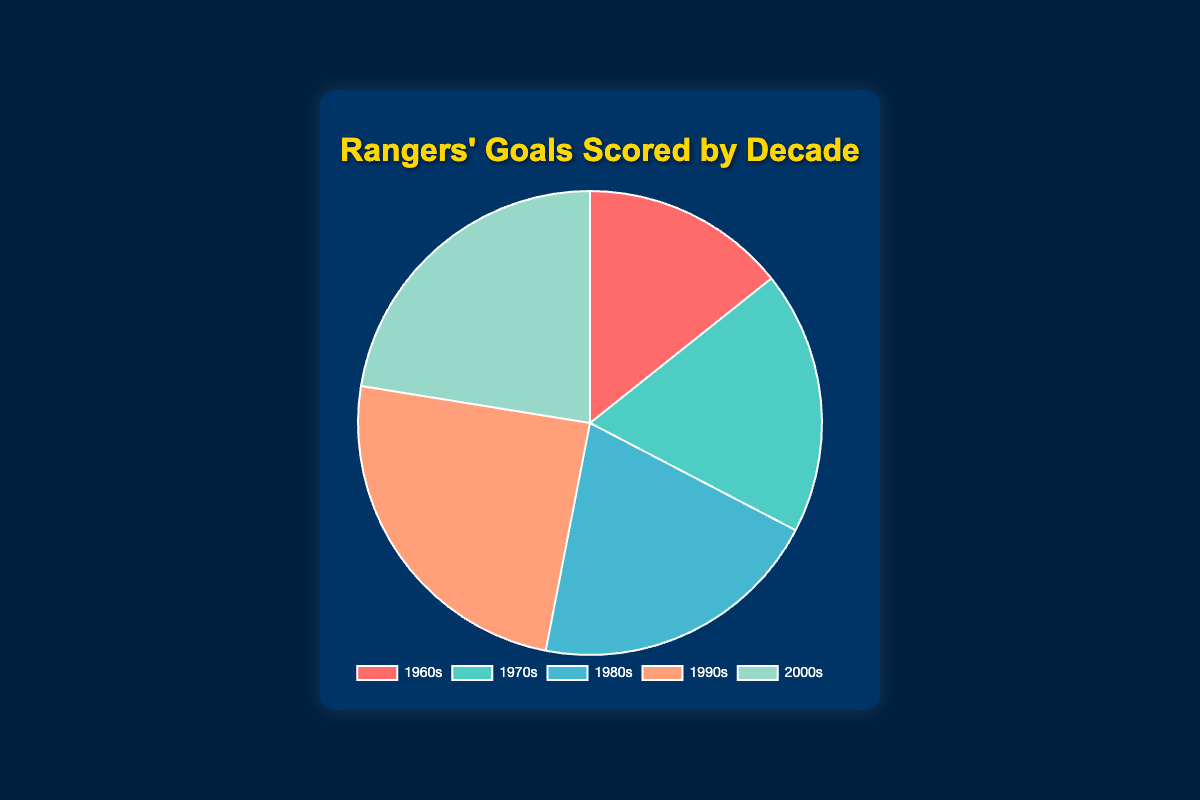What's the total number of goals scored across all decades? Add the goals scored in each decade: 350 (1960s) + 450 (1970s) + 500 (1980s) + 600 (1990s) + 550 (2000s) = 2450
Answer: 2450 Which decade has the highest number of goals scored? Look at the chart to identify the decade with the largest slice. The 1990s have the largest slice, representing 600 goals.
Answer: 1990s How many more goals were scored in the 1990s compared to the 1960s? Subtract the number of goals scored in the 1960s from the goals scored in the 1990s: 600 (1990s) - 350 (1960s) = 250
Answer: 250 What's the average number of goals scored per decade? Sum all the goals and divide by the number of decades: (350 + 450 + 500 + 600 + 550) / 5 = 2450 / 5 = 490
Answer: 490 What percentage of the total goals were scored in the 1980s? Calculate the percentage: (500 (1980s) / 2450 (total)) * 100 ≈ 20.41%
Answer: 20.41% What is the difference in goals scored between the 1980s and the 2000s? Subtract the number of goals scored in the 1980s from the number in the 2000s: 550 (2000s) - 500 (1980s) = 50
Answer: 50 Which decade has the smallest slice in the pie chart? Identify the decade with the smallest slice. The 1960s have the smallest slice, representing 350 goals.
Answer: 1960s If the goals in the 1980s increased by 10%, how many goals would that be? Calculate the increased number of goals: 500 (1980s) * 1.10 = 550
Answer: 550 What is the ratio of goals scored in the 1970s to the 1990s? Divide the goals scored in the 1970s by the goals scored in the 1990s: 450 (1970s) / 600 (1990s) = 0.75
Answer: 0.75 